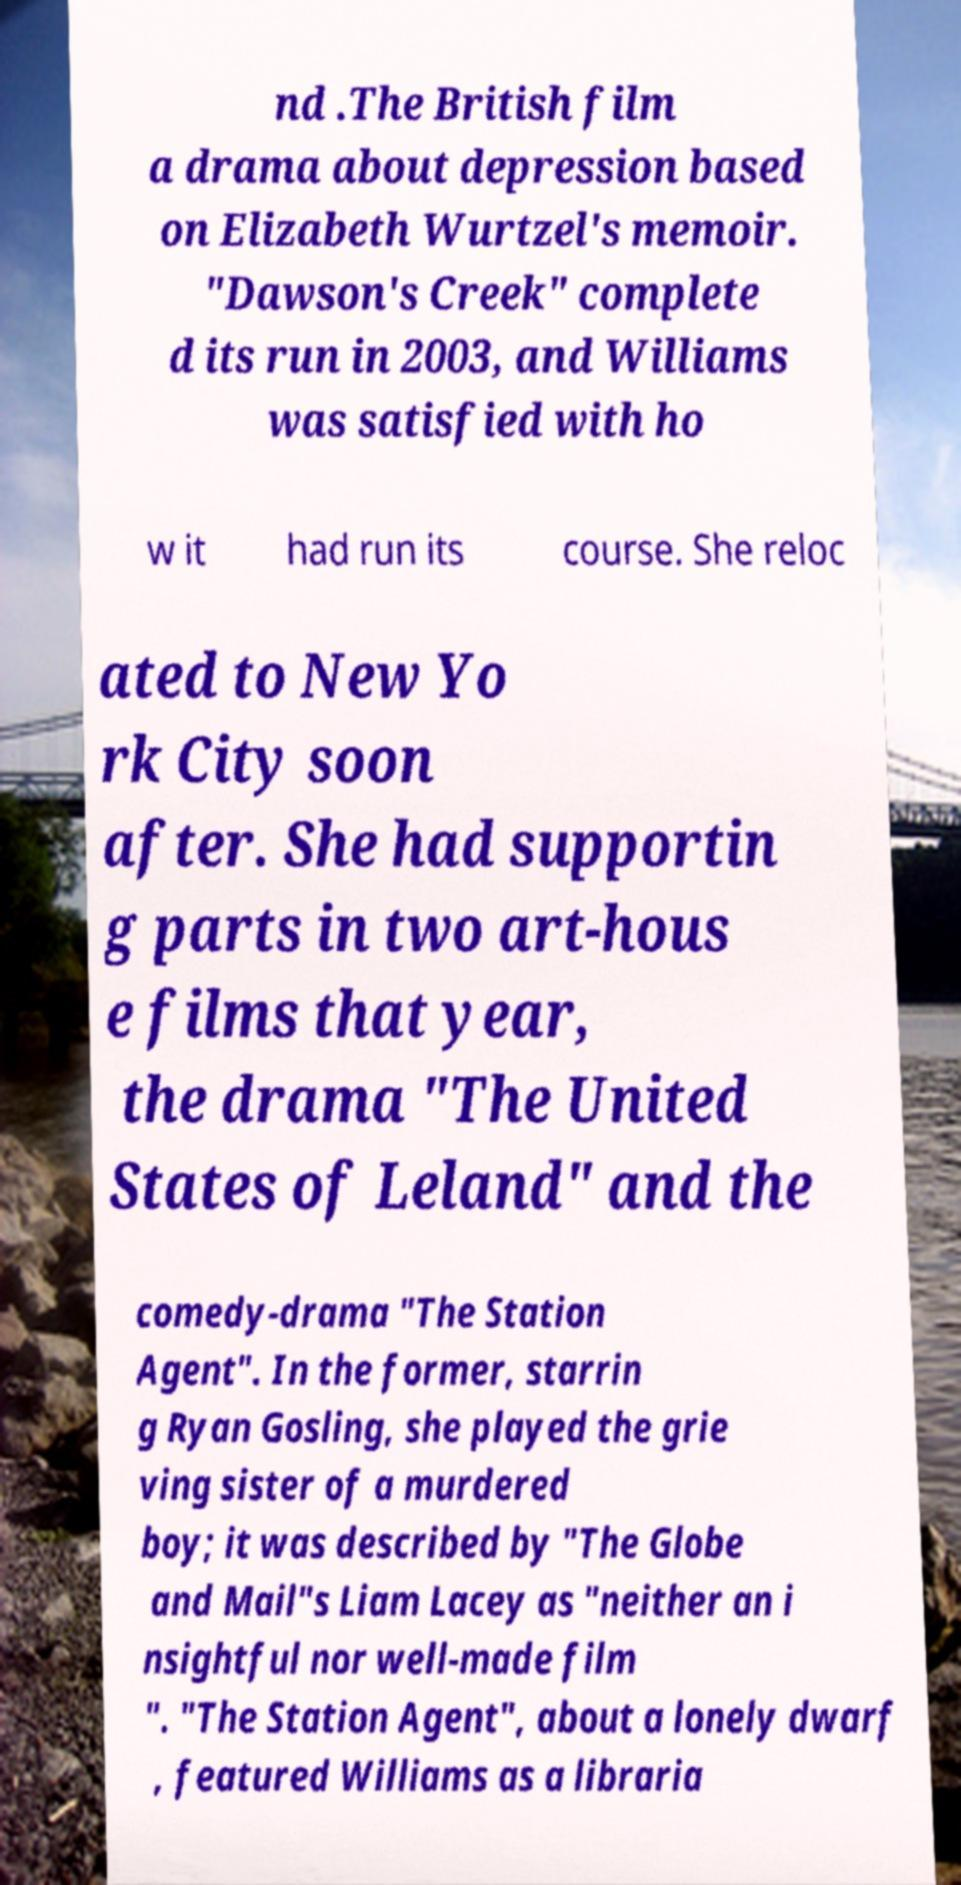I need the written content from this picture converted into text. Can you do that? nd .The British film a drama about depression based on Elizabeth Wurtzel's memoir. "Dawson's Creek" complete d its run in 2003, and Williams was satisfied with ho w it had run its course. She reloc ated to New Yo rk City soon after. She had supportin g parts in two art-hous e films that year, the drama "The United States of Leland" and the comedy-drama "The Station Agent". In the former, starrin g Ryan Gosling, she played the grie ving sister of a murdered boy; it was described by "The Globe and Mail"s Liam Lacey as "neither an i nsightful nor well-made film ". "The Station Agent", about a lonely dwarf , featured Williams as a libraria 